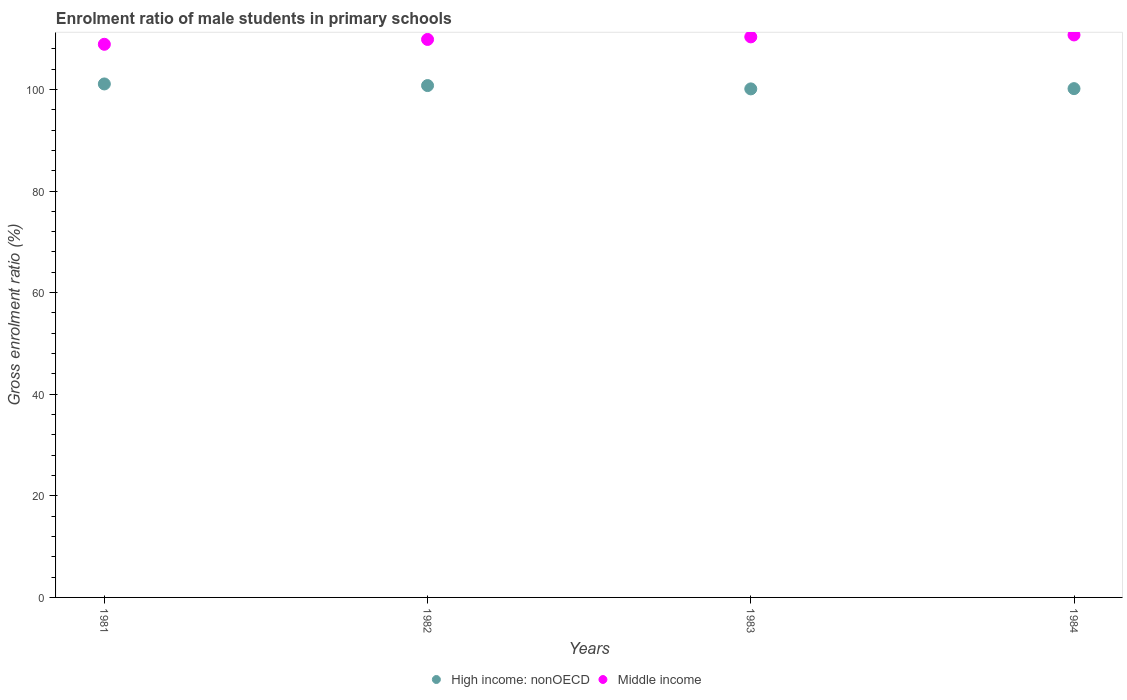What is the enrolment ratio of male students in primary schools in High income: nonOECD in 1982?
Offer a terse response. 100.76. Across all years, what is the maximum enrolment ratio of male students in primary schools in Middle income?
Your response must be concise. 110.72. Across all years, what is the minimum enrolment ratio of male students in primary schools in High income: nonOECD?
Offer a terse response. 100.1. In which year was the enrolment ratio of male students in primary schools in High income: nonOECD maximum?
Offer a very short reply. 1981. In which year was the enrolment ratio of male students in primary schools in Middle income minimum?
Provide a short and direct response. 1981. What is the total enrolment ratio of male students in primary schools in High income: nonOECD in the graph?
Your answer should be very brief. 402.08. What is the difference between the enrolment ratio of male students in primary schools in High income: nonOECD in 1981 and that in 1982?
Your answer should be compact. 0.32. What is the difference between the enrolment ratio of male students in primary schools in Middle income in 1981 and the enrolment ratio of male students in primary schools in High income: nonOECD in 1982?
Your answer should be very brief. 8.13. What is the average enrolment ratio of male students in primary schools in Middle income per year?
Provide a succinct answer. 109.94. In the year 1983, what is the difference between the enrolment ratio of male students in primary schools in High income: nonOECD and enrolment ratio of male students in primary schools in Middle income?
Your response must be concise. -10.24. In how many years, is the enrolment ratio of male students in primary schools in High income: nonOECD greater than 68 %?
Offer a very short reply. 4. What is the ratio of the enrolment ratio of male students in primary schools in High income: nonOECD in 1981 to that in 1983?
Give a very brief answer. 1.01. What is the difference between the highest and the second highest enrolment ratio of male students in primary schools in High income: nonOECD?
Provide a short and direct response. 0.32. What is the difference between the highest and the lowest enrolment ratio of male students in primary schools in High income: nonOECD?
Give a very brief answer. 0.97. Is the sum of the enrolment ratio of male students in primary schools in Middle income in 1982 and 1984 greater than the maximum enrolment ratio of male students in primary schools in High income: nonOECD across all years?
Offer a terse response. Yes. Does the enrolment ratio of male students in primary schools in High income: nonOECD monotonically increase over the years?
Keep it short and to the point. No. Is the enrolment ratio of male students in primary schools in Middle income strictly greater than the enrolment ratio of male students in primary schools in High income: nonOECD over the years?
Ensure brevity in your answer.  Yes. Is the enrolment ratio of male students in primary schools in High income: nonOECD strictly less than the enrolment ratio of male students in primary schools in Middle income over the years?
Provide a short and direct response. Yes. Does the graph contain grids?
Your answer should be very brief. No. Where does the legend appear in the graph?
Offer a very short reply. Bottom center. How are the legend labels stacked?
Your answer should be very brief. Horizontal. What is the title of the graph?
Your answer should be very brief. Enrolment ratio of male students in primary schools. What is the label or title of the X-axis?
Offer a terse response. Years. What is the label or title of the Y-axis?
Provide a succinct answer. Gross enrolment ratio (%). What is the Gross enrolment ratio (%) of High income: nonOECD in 1981?
Offer a very short reply. 101.07. What is the Gross enrolment ratio (%) in Middle income in 1981?
Provide a short and direct response. 108.88. What is the Gross enrolment ratio (%) of High income: nonOECD in 1982?
Offer a very short reply. 100.76. What is the Gross enrolment ratio (%) of Middle income in 1982?
Your answer should be very brief. 109.83. What is the Gross enrolment ratio (%) of High income: nonOECD in 1983?
Offer a very short reply. 100.1. What is the Gross enrolment ratio (%) of Middle income in 1983?
Ensure brevity in your answer.  110.34. What is the Gross enrolment ratio (%) of High income: nonOECD in 1984?
Provide a short and direct response. 100.15. What is the Gross enrolment ratio (%) in Middle income in 1984?
Offer a very short reply. 110.72. Across all years, what is the maximum Gross enrolment ratio (%) of High income: nonOECD?
Make the answer very short. 101.07. Across all years, what is the maximum Gross enrolment ratio (%) of Middle income?
Your response must be concise. 110.72. Across all years, what is the minimum Gross enrolment ratio (%) in High income: nonOECD?
Keep it short and to the point. 100.1. Across all years, what is the minimum Gross enrolment ratio (%) of Middle income?
Your response must be concise. 108.88. What is the total Gross enrolment ratio (%) of High income: nonOECD in the graph?
Your response must be concise. 402.08. What is the total Gross enrolment ratio (%) in Middle income in the graph?
Ensure brevity in your answer.  439.77. What is the difference between the Gross enrolment ratio (%) in High income: nonOECD in 1981 and that in 1982?
Your answer should be compact. 0.32. What is the difference between the Gross enrolment ratio (%) in Middle income in 1981 and that in 1982?
Offer a terse response. -0.95. What is the difference between the Gross enrolment ratio (%) of High income: nonOECD in 1981 and that in 1983?
Provide a succinct answer. 0.97. What is the difference between the Gross enrolment ratio (%) of Middle income in 1981 and that in 1983?
Offer a very short reply. -1.46. What is the difference between the Gross enrolment ratio (%) of High income: nonOECD in 1981 and that in 1984?
Provide a succinct answer. 0.92. What is the difference between the Gross enrolment ratio (%) in Middle income in 1981 and that in 1984?
Keep it short and to the point. -1.84. What is the difference between the Gross enrolment ratio (%) in High income: nonOECD in 1982 and that in 1983?
Provide a short and direct response. 0.65. What is the difference between the Gross enrolment ratio (%) in Middle income in 1982 and that in 1983?
Your answer should be very brief. -0.5. What is the difference between the Gross enrolment ratio (%) of High income: nonOECD in 1982 and that in 1984?
Your answer should be very brief. 0.6. What is the difference between the Gross enrolment ratio (%) of Middle income in 1982 and that in 1984?
Keep it short and to the point. -0.89. What is the difference between the Gross enrolment ratio (%) of High income: nonOECD in 1983 and that in 1984?
Ensure brevity in your answer.  -0.05. What is the difference between the Gross enrolment ratio (%) in Middle income in 1983 and that in 1984?
Your answer should be very brief. -0.38. What is the difference between the Gross enrolment ratio (%) in High income: nonOECD in 1981 and the Gross enrolment ratio (%) in Middle income in 1982?
Keep it short and to the point. -8.76. What is the difference between the Gross enrolment ratio (%) in High income: nonOECD in 1981 and the Gross enrolment ratio (%) in Middle income in 1983?
Offer a very short reply. -9.26. What is the difference between the Gross enrolment ratio (%) of High income: nonOECD in 1981 and the Gross enrolment ratio (%) of Middle income in 1984?
Provide a succinct answer. -9.65. What is the difference between the Gross enrolment ratio (%) of High income: nonOECD in 1982 and the Gross enrolment ratio (%) of Middle income in 1983?
Your response must be concise. -9.58. What is the difference between the Gross enrolment ratio (%) of High income: nonOECD in 1982 and the Gross enrolment ratio (%) of Middle income in 1984?
Your answer should be very brief. -9.96. What is the difference between the Gross enrolment ratio (%) of High income: nonOECD in 1983 and the Gross enrolment ratio (%) of Middle income in 1984?
Ensure brevity in your answer.  -10.62. What is the average Gross enrolment ratio (%) of High income: nonOECD per year?
Your answer should be very brief. 100.52. What is the average Gross enrolment ratio (%) in Middle income per year?
Your answer should be compact. 109.94. In the year 1981, what is the difference between the Gross enrolment ratio (%) in High income: nonOECD and Gross enrolment ratio (%) in Middle income?
Offer a very short reply. -7.81. In the year 1982, what is the difference between the Gross enrolment ratio (%) in High income: nonOECD and Gross enrolment ratio (%) in Middle income?
Your answer should be compact. -9.08. In the year 1983, what is the difference between the Gross enrolment ratio (%) in High income: nonOECD and Gross enrolment ratio (%) in Middle income?
Offer a terse response. -10.24. In the year 1984, what is the difference between the Gross enrolment ratio (%) of High income: nonOECD and Gross enrolment ratio (%) of Middle income?
Offer a terse response. -10.57. What is the ratio of the Gross enrolment ratio (%) of Middle income in 1981 to that in 1982?
Offer a terse response. 0.99. What is the ratio of the Gross enrolment ratio (%) of High income: nonOECD in 1981 to that in 1983?
Your response must be concise. 1.01. What is the ratio of the Gross enrolment ratio (%) in High income: nonOECD in 1981 to that in 1984?
Ensure brevity in your answer.  1.01. What is the ratio of the Gross enrolment ratio (%) in Middle income in 1981 to that in 1984?
Offer a very short reply. 0.98. What is the ratio of the Gross enrolment ratio (%) of Middle income in 1982 to that in 1984?
Give a very brief answer. 0.99. What is the ratio of the Gross enrolment ratio (%) in High income: nonOECD in 1983 to that in 1984?
Give a very brief answer. 1. What is the ratio of the Gross enrolment ratio (%) in Middle income in 1983 to that in 1984?
Give a very brief answer. 1. What is the difference between the highest and the second highest Gross enrolment ratio (%) in High income: nonOECD?
Provide a succinct answer. 0.32. What is the difference between the highest and the second highest Gross enrolment ratio (%) of Middle income?
Make the answer very short. 0.38. What is the difference between the highest and the lowest Gross enrolment ratio (%) of High income: nonOECD?
Ensure brevity in your answer.  0.97. What is the difference between the highest and the lowest Gross enrolment ratio (%) in Middle income?
Give a very brief answer. 1.84. 